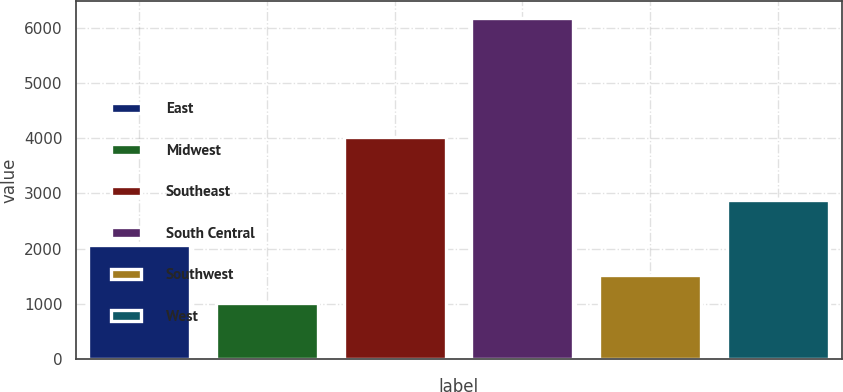Convert chart. <chart><loc_0><loc_0><loc_500><loc_500><bar_chart><fcel>East<fcel>Midwest<fcel>Southeast<fcel>South Central<fcel>Southwest<fcel>West<nl><fcel>2066<fcel>1005<fcel>4019<fcel>6169<fcel>1521.4<fcel>2878<nl></chart> 